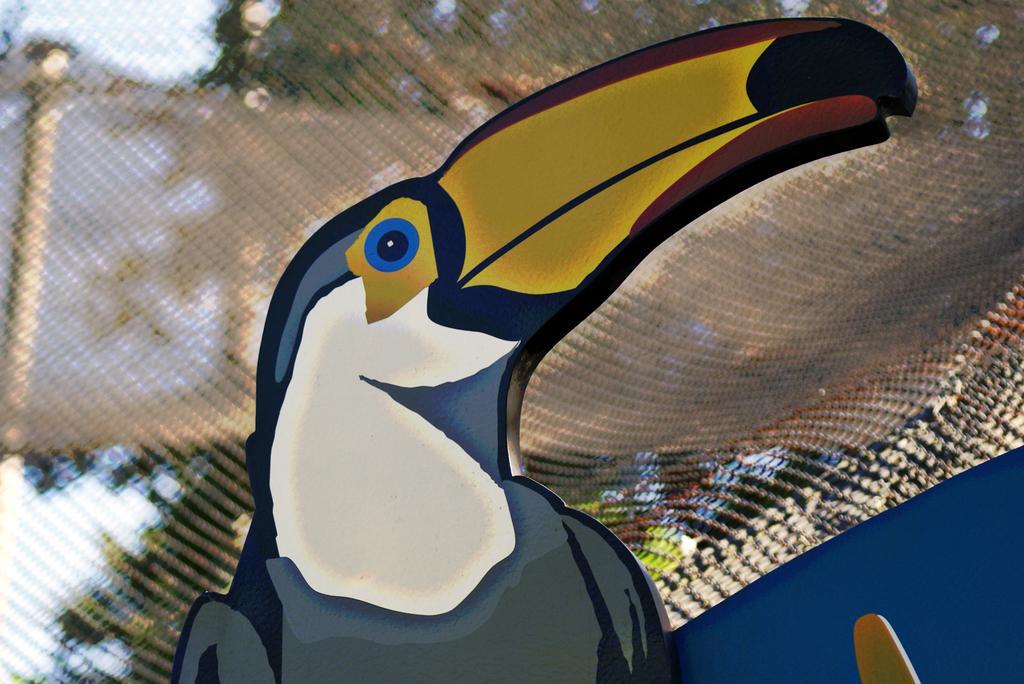Could you give a brief overview of what you see in this image? In this image we can see the close view of a bird and the background is blurred. 